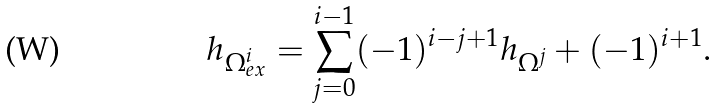Convert formula to latex. <formula><loc_0><loc_0><loc_500><loc_500>h _ { \Omega ^ { i } _ { e x } } = \sum _ { j = 0 } ^ { i - 1 } ( - 1 ) ^ { i - j + 1 } h _ { \Omega ^ { j } } + ( - 1 ) ^ { i + 1 } .</formula> 